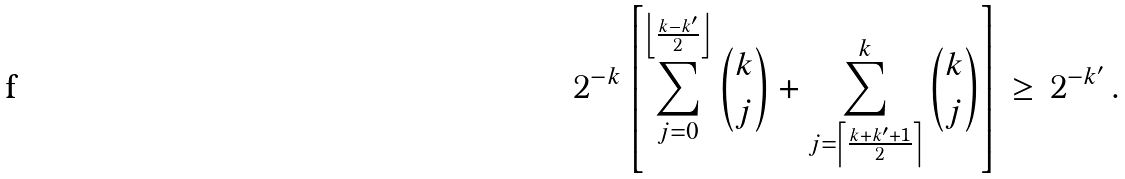Convert formula to latex. <formula><loc_0><loc_0><loc_500><loc_500>2 ^ { - k } \left [ \sum _ { j = 0 } ^ { \left \lfloor \frac { k - k ^ { \prime } } { 2 } \right \rfloor } \binom { k } { j } + \sum _ { j = \left \lceil \frac { k + k ^ { \prime } + 1 } { 2 } \right \rceil } ^ { k } \binom { k } { j } \right ] \, \geq \, 2 ^ { - k ^ { \prime } } \, .</formula> 